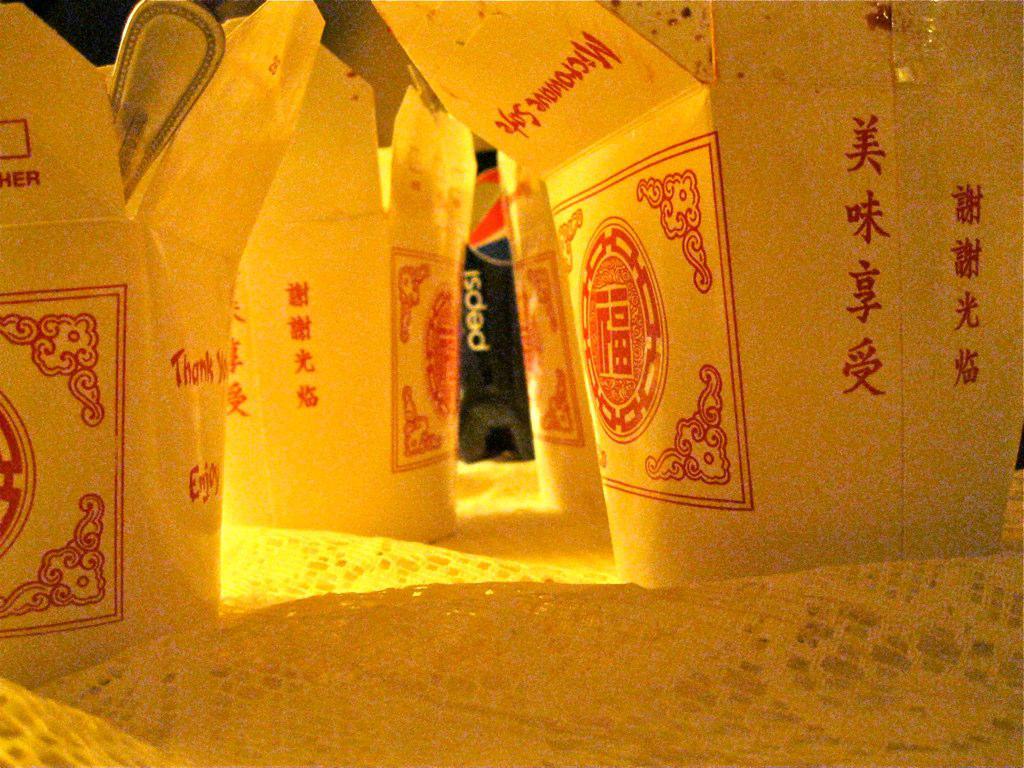What does the box in the center say?
Offer a very short reply. Microwave safe. 